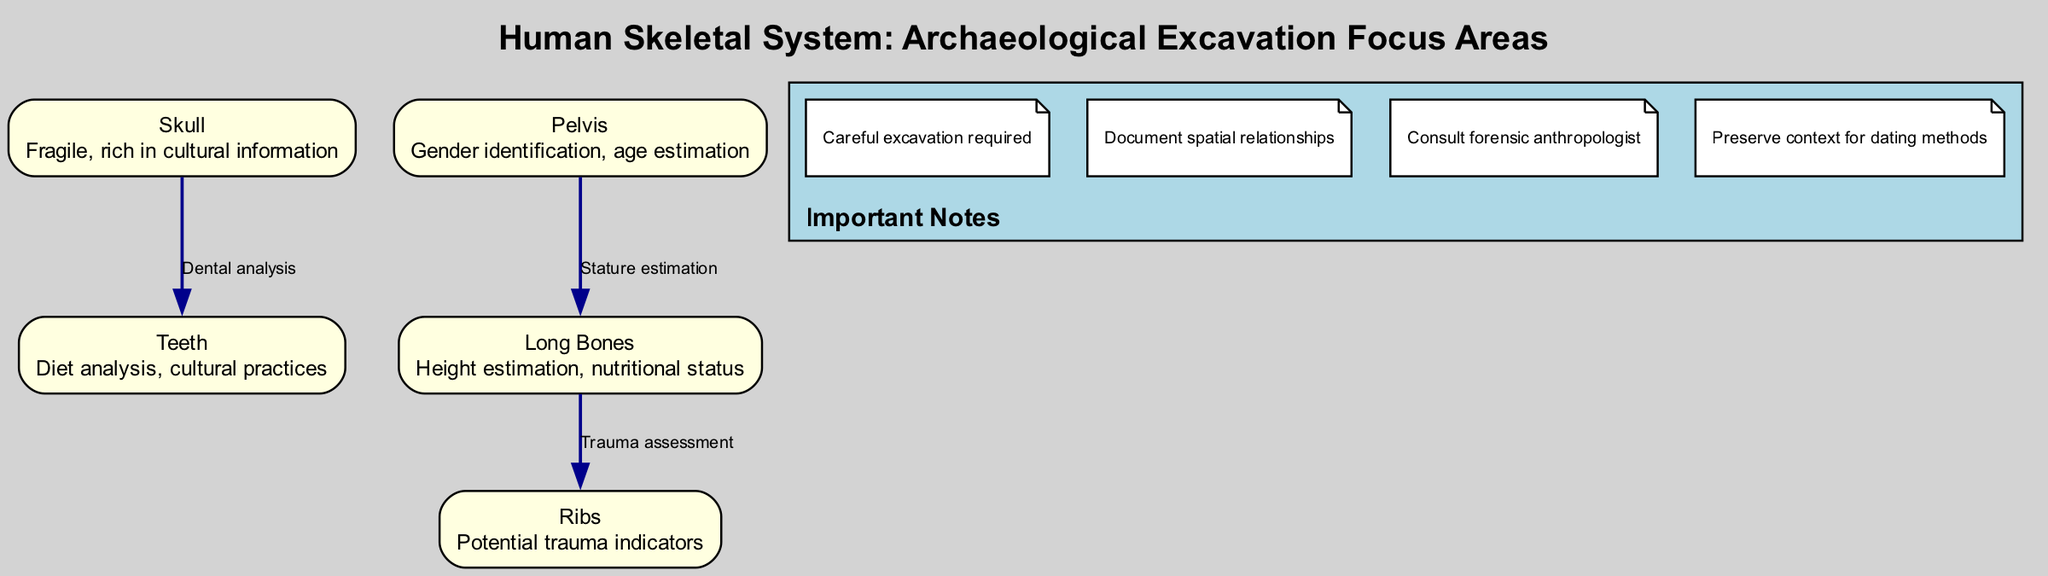What is highlighted as fragile in the skeletal system? The diagram lists the "Skull" as fragile, indicating its importance in archaeological contexts. The skull is noted to be rich in cultural information, making it a primary area of concern.
Answer: Skull How many nodes are represented in the diagram? The diagram features five distinct nodes representing different parts of the human skeletal system: Skull, Pelvis, Long Bones, Teeth, and Ribs. Counting these gives a total of five nodes.
Answer: 5 What are the two key functions associated with the Pelvis node? The Pelvis node mentions "Gender identification" and "age estimation" as its key functions in understanding skeletal remains during excavations.
Answer: Gender identification, age estimation Which node is directly linked to both the Skull and Ribs nodes? The Teeth node is directly connected to the Skull node via "Dental analysis," and the Long Bones node connects to the Ribs node through "Trauma assessment." Thus, the Teeth node serves as a significant connection.
Answer: Teeth What is the relationship type between the Long Bones and Ribs nodes? The diagram indicates that the relationship between the Long Bones and Ribs nodes is defined as "Trauma assessment," suggesting a link in identifying injury patterns from skeletal remains.
Answer: Trauma assessment What should be done to preserve context for dating methods according to the notes? The notes specifically advise to "Preserve context for dating methods," ensuring that excavation practices maintain the original position and arrangement of findings for accurate dating.
Answer: Preserve context for dating methods How many edges are there in total connecting the nodes? Examining the diagram, there are three edges connecting the various nodes: from Skull to Teeth, Pelvis to Long Bones, and Long Bones to Ribs, resulting in a total of three edges.
Answer: 3 Which node provides insights into dietary analysis? The Teeth node provides insights into dietary analysis as indicated in its description, making it crucial for understanding human dietary practices.
Answer: Teeth What is one of the important notes related to the excavation process? One critical note listed in the diagram is "Careful excavation required," highlighting the need for meticulous handling during the archaeological process to protect findings.
Answer: Careful excavation required 